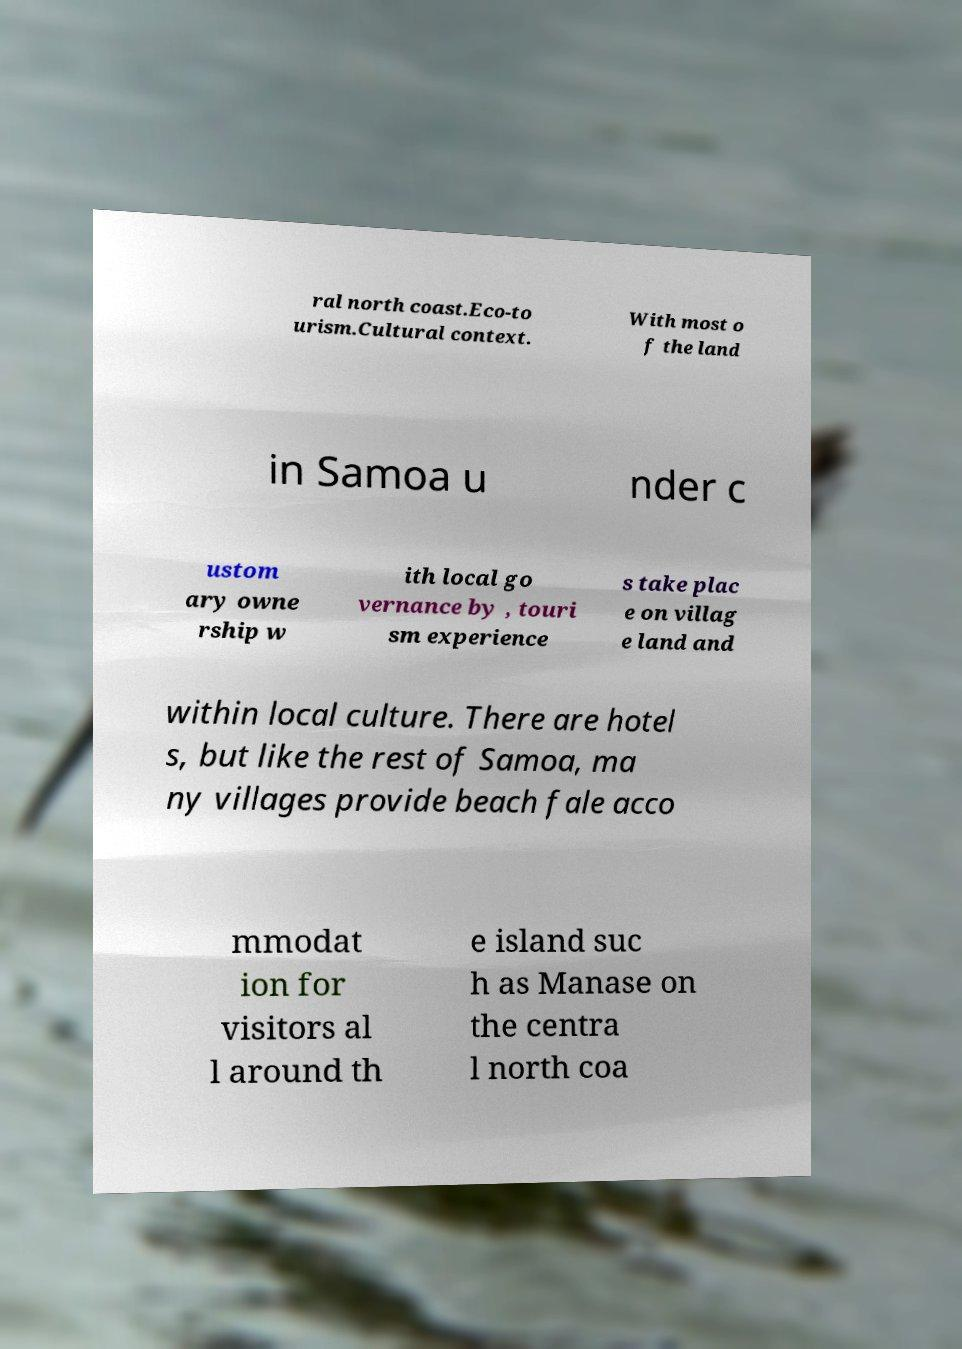Can you accurately transcribe the text from the provided image for me? ral north coast.Eco-to urism.Cultural context. With most o f the land in Samoa u nder c ustom ary owne rship w ith local go vernance by , touri sm experience s take plac e on villag e land and within local culture. There are hotel s, but like the rest of Samoa, ma ny villages provide beach fale acco mmodat ion for visitors al l around th e island suc h as Manase on the centra l north coa 